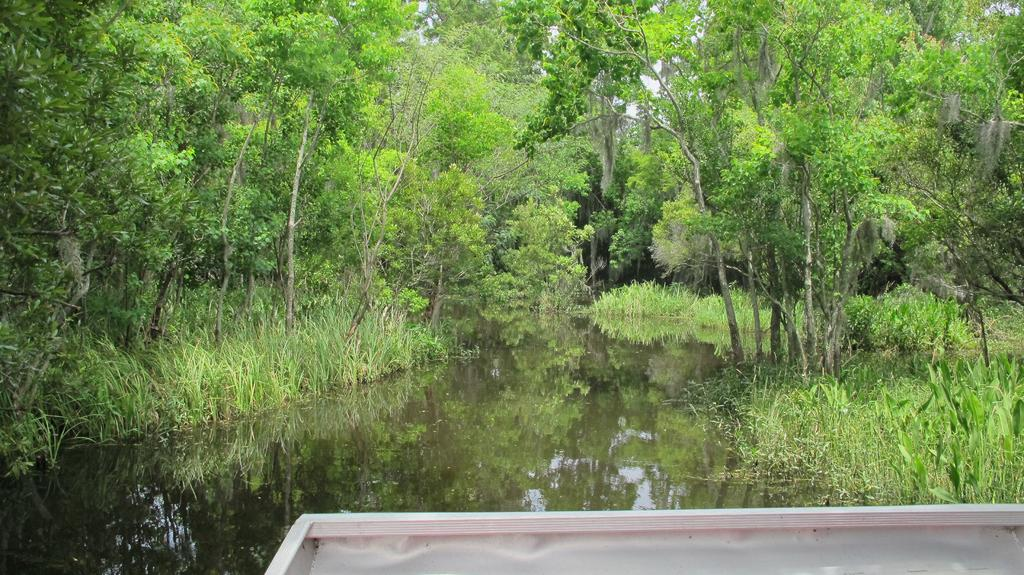What type of natural elements are present in the image? There are trees and plants in the image. What body of water can be seen in the image? There is a lake in the middle of the image. Can you describe the object at the bottom of the image? Unfortunately, the facts provided do not give any information about the object at the bottom of the image. What type of cabbage is growing near the lake in the image? There is no cabbage present in the image. How does the object at the bottom of the image show respect to the environment? The facts provided do not give any information about the object at the bottom of the image, so we cannot determine if it shows respect to the environment. 